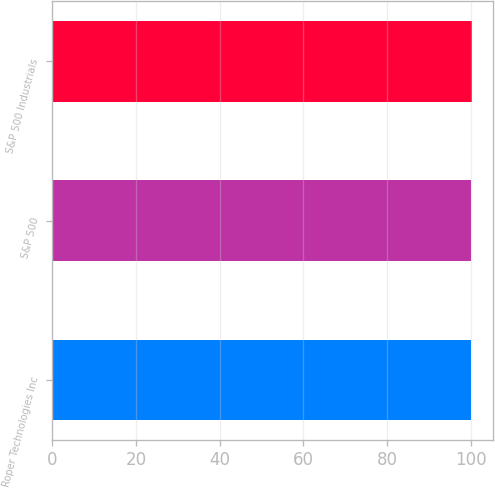<chart> <loc_0><loc_0><loc_500><loc_500><bar_chart><fcel>Roper Technologies Inc<fcel>S&P 500<fcel>S&P 500 Industrials<nl><fcel>100<fcel>100.1<fcel>100.2<nl></chart> 